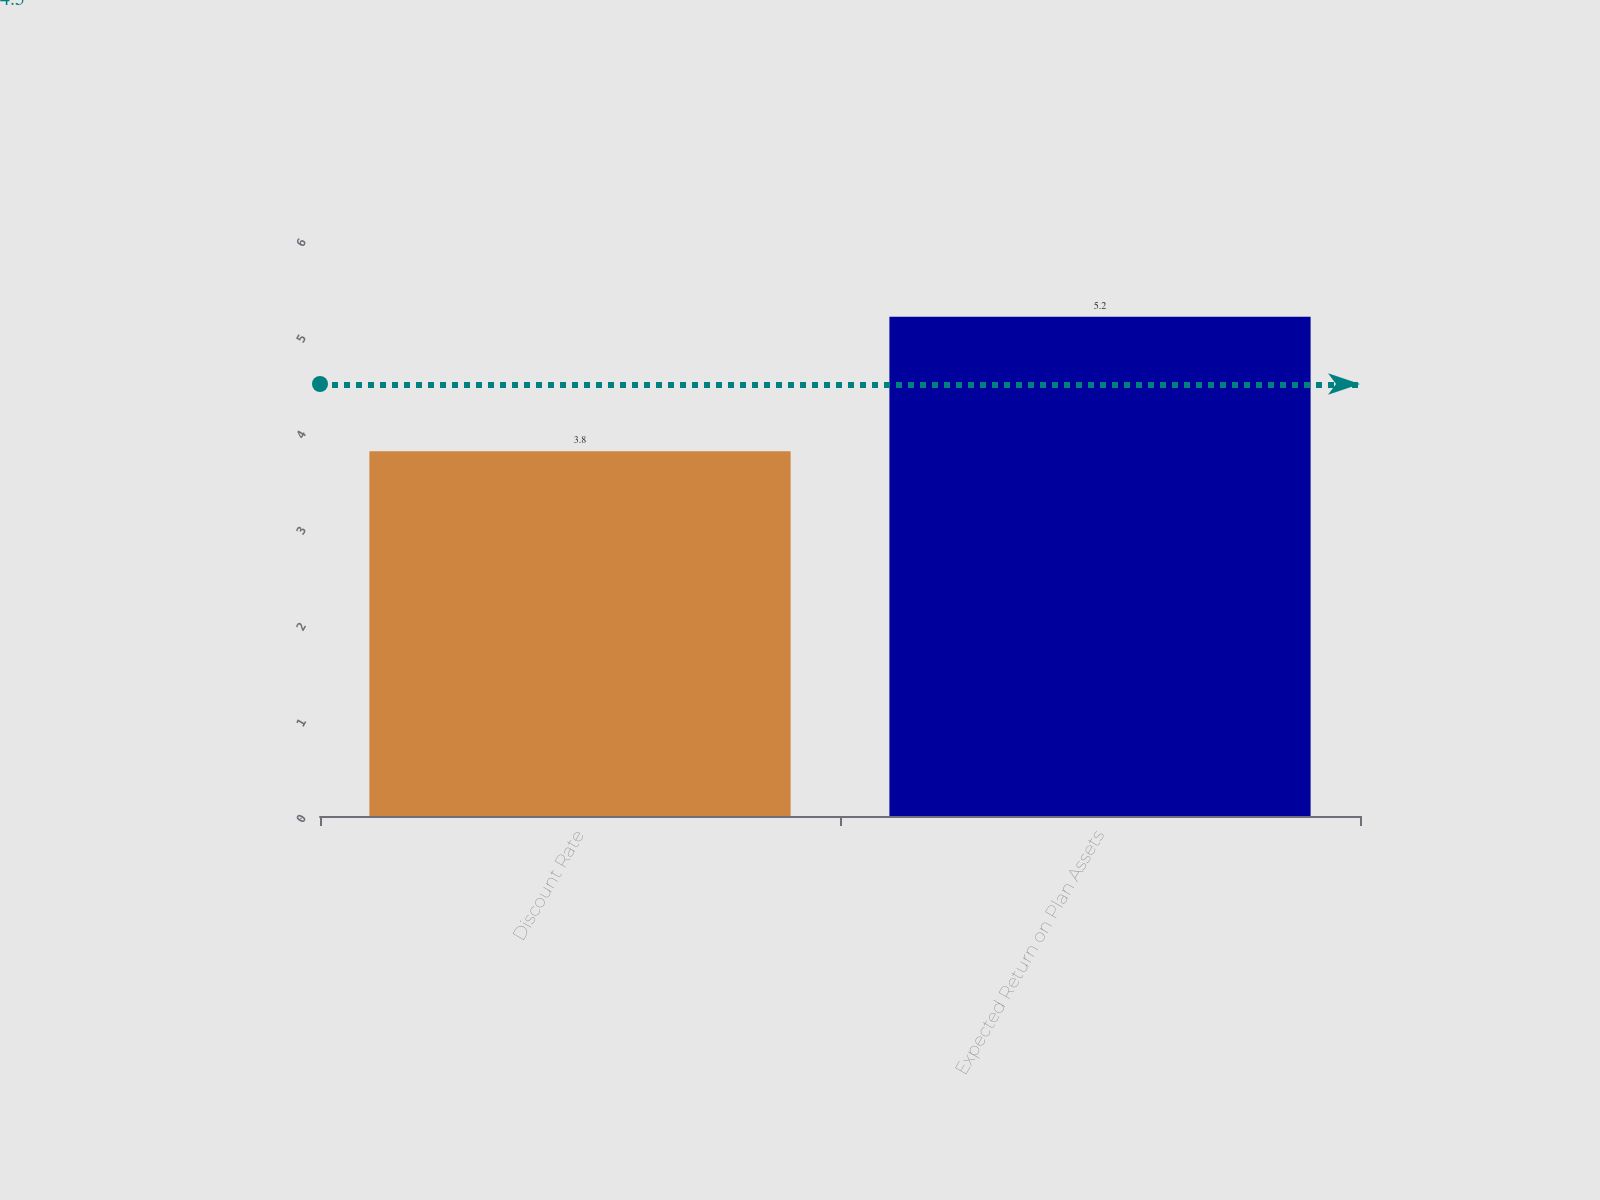Convert chart to OTSL. <chart><loc_0><loc_0><loc_500><loc_500><bar_chart><fcel>Discount Rate<fcel>Expected Return on Plan Assets<nl><fcel>3.8<fcel>5.2<nl></chart> 